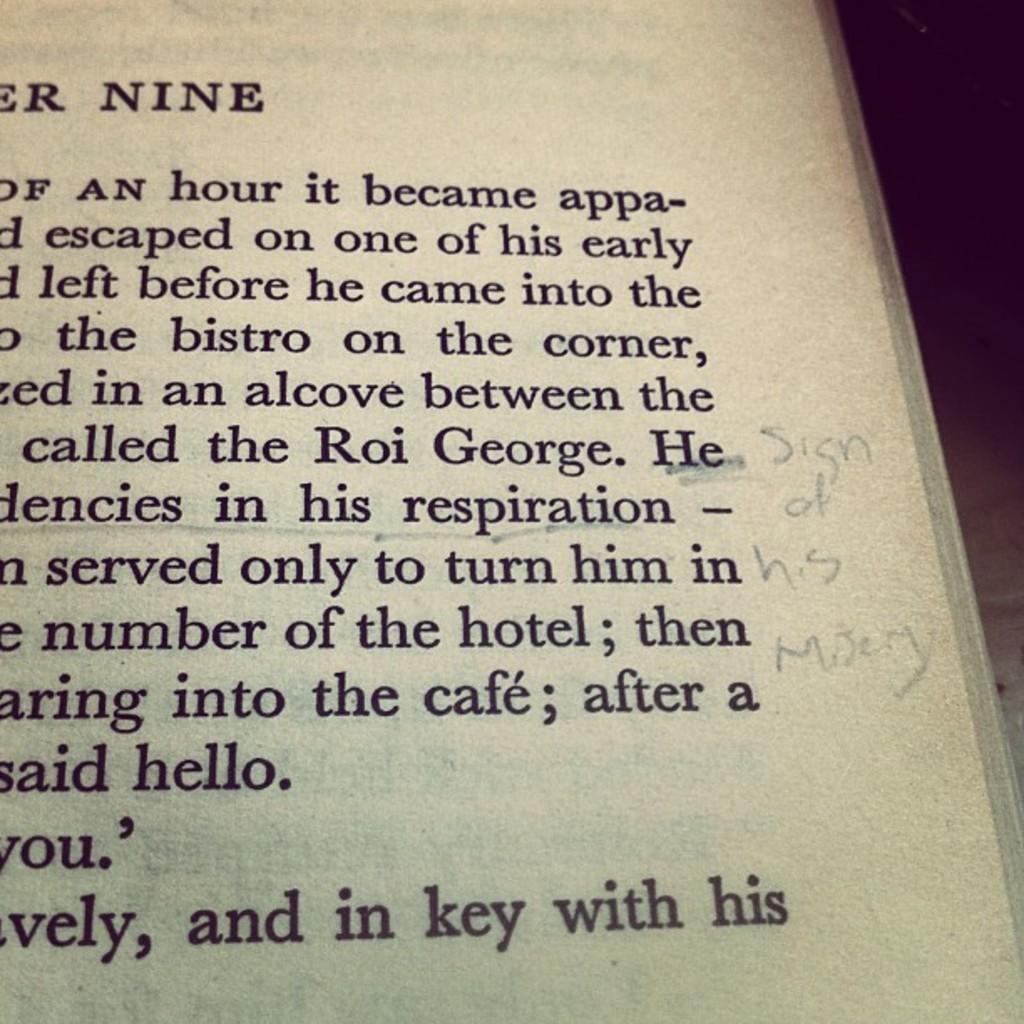What footnote was made in the margin?
Your answer should be compact. Sign of his misery. 